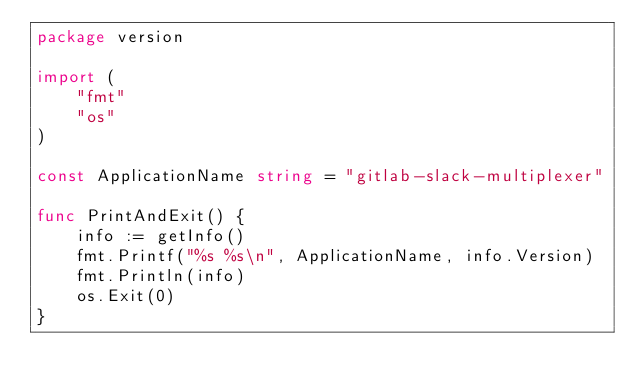<code> <loc_0><loc_0><loc_500><loc_500><_Go_>package version

import (
	"fmt"
	"os"
)

const ApplicationName string = "gitlab-slack-multiplexer"

func PrintAndExit() {
	info := getInfo()
	fmt.Printf("%s %s\n", ApplicationName, info.Version)
	fmt.Println(info)
	os.Exit(0)
}
</code> 